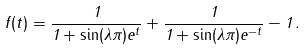<formula> <loc_0><loc_0><loc_500><loc_500>f ( t ) = \frac { 1 } { 1 + \sin ( \lambda \pi ) e ^ { t } } + \frac { 1 } { 1 + \sin ( \lambda \pi ) e ^ { - t } } - 1 \, .</formula> 